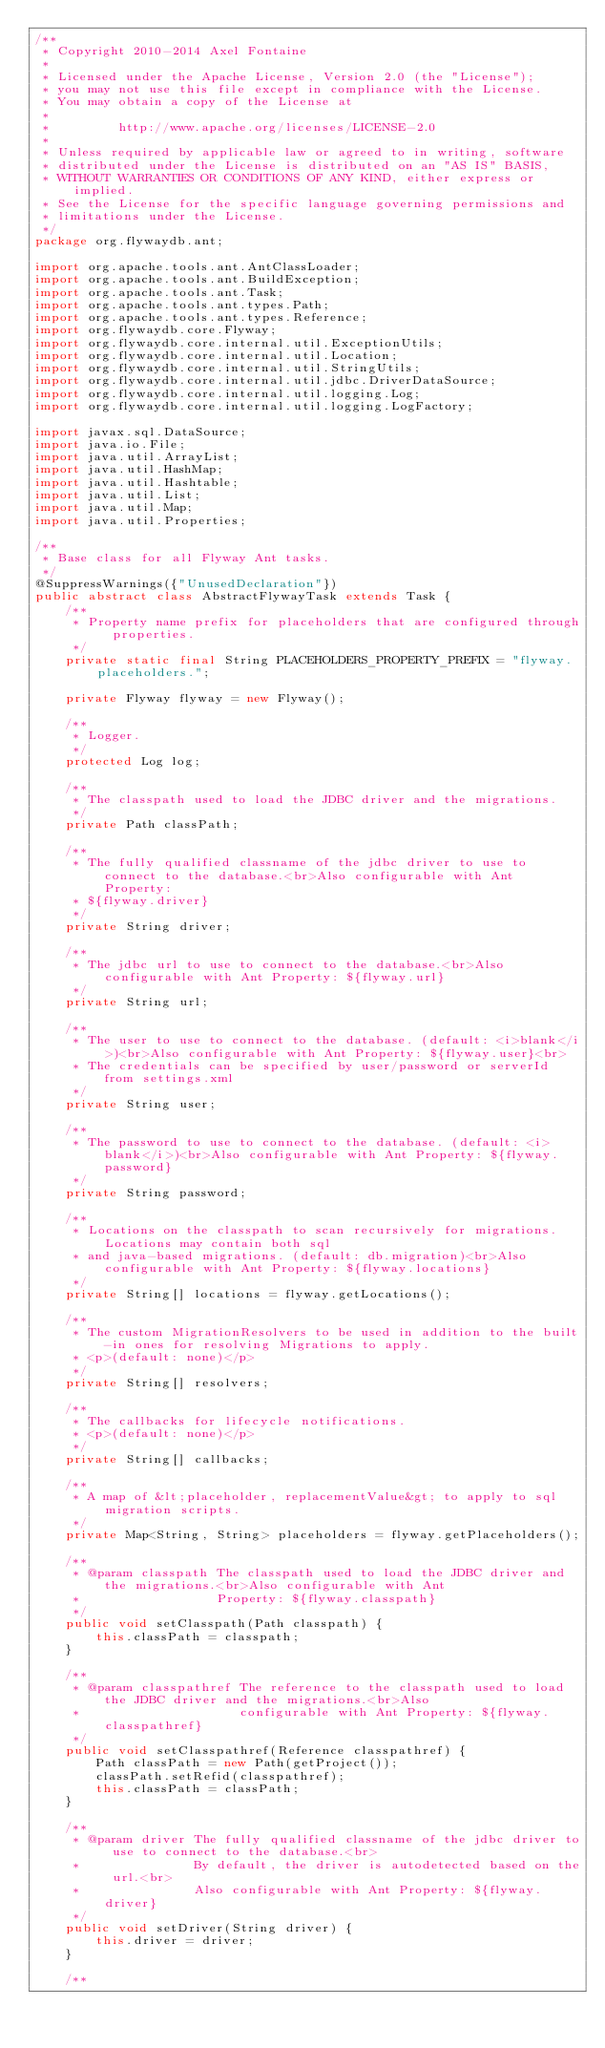<code> <loc_0><loc_0><loc_500><loc_500><_Java_>/**
 * Copyright 2010-2014 Axel Fontaine
 *
 * Licensed under the Apache License, Version 2.0 (the "License");
 * you may not use this file except in compliance with the License.
 * You may obtain a copy of the License at
 *
 *         http://www.apache.org/licenses/LICENSE-2.0
 *
 * Unless required by applicable law or agreed to in writing, software
 * distributed under the License is distributed on an "AS IS" BASIS,
 * WITHOUT WARRANTIES OR CONDITIONS OF ANY KIND, either express or implied.
 * See the License for the specific language governing permissions and
 * limitations under the License.
 */
package org.flywaydb.ant;

import org.apache.tools.ant.AntClassLoader;
import org.apache.tools.ant.BuildException;
import org.apache.tools.ant.Task;
import org.apache.tools.ant.types.Path;
import org.apache.tools.ant.types.Reference;
import org.flywaydb.core.Flyway;
import org.flywaydb.core.internal.util.ExceptionUtils;
import org.flywaydb.core.internal.util.Location;
import org.flywaydb.core.internal.util.StringUtils;
import org.flywaydb.core.internal.util.jdbc.DriverDataSource;
import org.flywaydb.core.internal.util.logging.Log;
import org.flywaydb.core.internal.util.logging.LogFactory;

import javax.sql.DataSource;
import java.io.File;
import java.util.ArrayList;
import java.util.HashMap;
import java.util.Hashtable;
import java.util.List;
import java.util.Map;
import java.util.Properties;

/**
 * Base class for all Flyway Ant tasks.
 */
@SuppressWarnings({"UnusedDeclaration"})
public abstract class AbstractFlywayTask extends Task {
    /**
     * Property name prefix for placeholders that are configured through properties.
     */
    private static final String PLACEHOLDERS_PROPERTY_PREFIX = "flyway.placeholders.";

    private Flyway flyway = new Flyway();

    /**
     * Logger.
     */
    protected Log log;

    /**
     * The classpath used to load the JDBC driver and the migrations.
     */
    private Path classPath;

    /**
     * The fully qualified classname of the jdbc driver to use to connect to the database.<br>Also configurable with Ant Property:
     * ${flyway.driver}
     */
    private String driver;

    /**
     * The jdbc url to use to connect to the database.<br>Also configurable with Ant Property: ${flyway.url}
     */
    private String url;

    /**
     * The user to use to connect to the database. (default: <i>blank</i>)<br>Also configurable with Ant Property: ${flyway.user}<br>
     * The credentials can be specified by user/password or serverId from settings.xml
     */
    private String user;

    /**
     * The password to use to connect to the database. (default: <i>blank</i>)<br>Also configurable with Ant Property: ${flyway.password}
     */
    private String password;

    /**
     * Locations on the classpath to scan recursively for migrations. Locations may contain both sql
     * and java-based migrations. (default: db.migration)<br>Also configurable with Ant Property: ${flyway.locations}
     */
    private String[] locations = flyway.getLocations();

    /**
     * The custom MigrationResolvers to be used in addition to the built-in ones for resolving Migrations to apply.
     * <p>(default: none)</p>
     */
    private String[] resolvers;

    /**
     * The callbacks for lifecycle notifications.
     * <p>(default: none)</p>
     */
    private String[] callbacks;

    /**
     * A map of &lt;placeholder, replacementValue&gt; to apply to sql migration scripts.
     */
    private Map<String, String> placeholders = flyway.getPlaceholders();

    /**
     * @param classpath The classpath used to load the JDBC driver and the migrations.<br>Also configurable with Ant
     *                  Property: ${flyway.classpath}
     */
    public void setClasspath(Path classpath) {
        this.classPath = classpath;
    }

    /**
     * @param classpathref The reference to the classpath used to load the JDBC driver and the migrations.<br>Also
     *                     configurable with Ant Property: ${flyway.classpathref}
     */
    public void setClasspathref(Reference classpathref) {
        Path classPath = new Path(getProject());
        classPath.setRefid(classpathref);
        this.classPath = classPath;
    }

    /**
     * @param driver The fully qualified classname of the jdbc driver to use to connect to the database.<br>
     *               By default, the driver is autodetected based on the url.<br>
     *               Also configurable with Ant Property: ${flyway.driver}
     */
    public void setDriver(String driver) {
        this.driver = driver;
    }

    /**</code> 